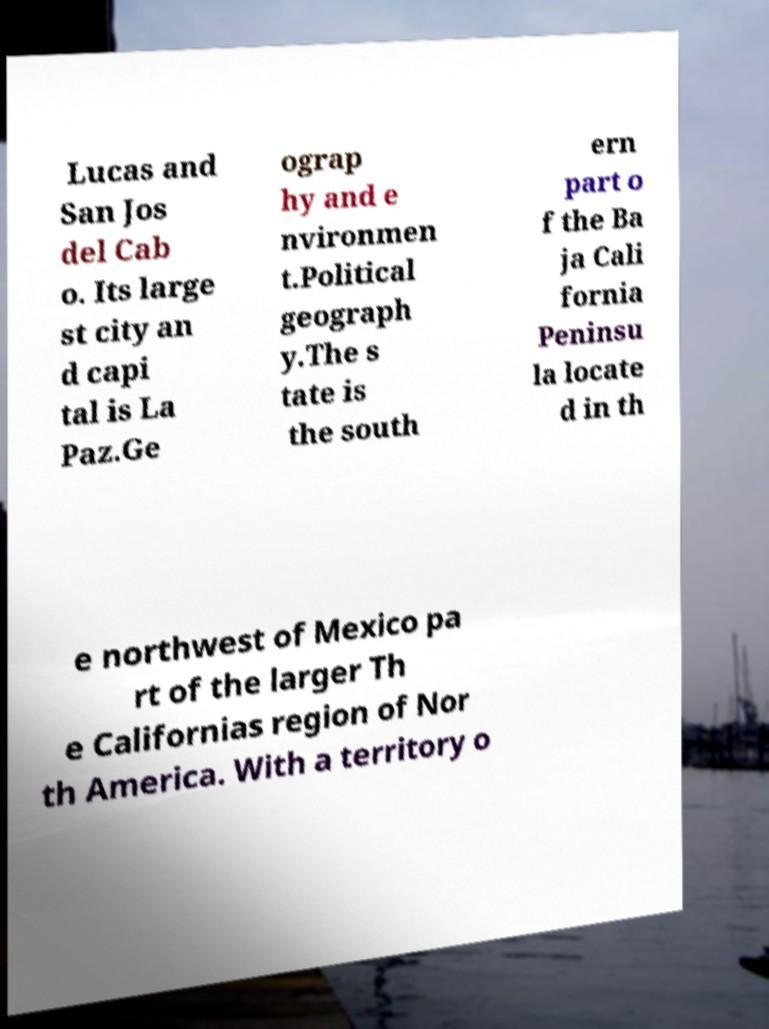Can you read and provide the text displayed in the image?This photo seems to have some interesting text. Can you extract and type it out for me? Lucas and San Jos del Cab o. Its large st city an d capi tal is La Paz.Ge ograp hy and e nvironmen t.Political geograph y.The s tate is the south ern part o f the Ba ja Cali fornia Peninsu la locate d in th e northwest of Mexico pa rt of the larger Th e Californias region of Nor th America. With a territory o 